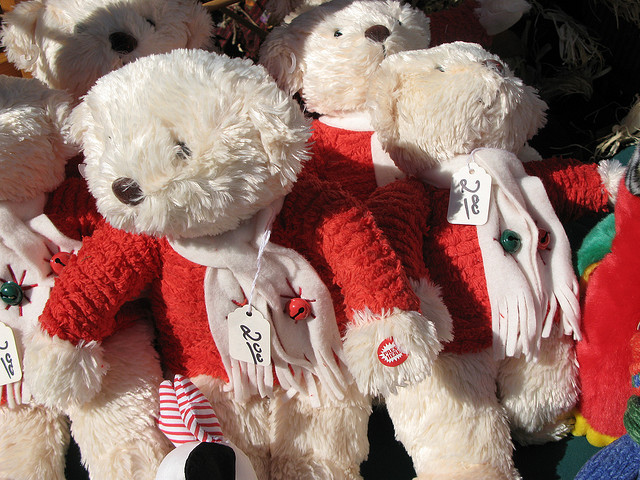Extract all visible text content from this image. 18 2 200 